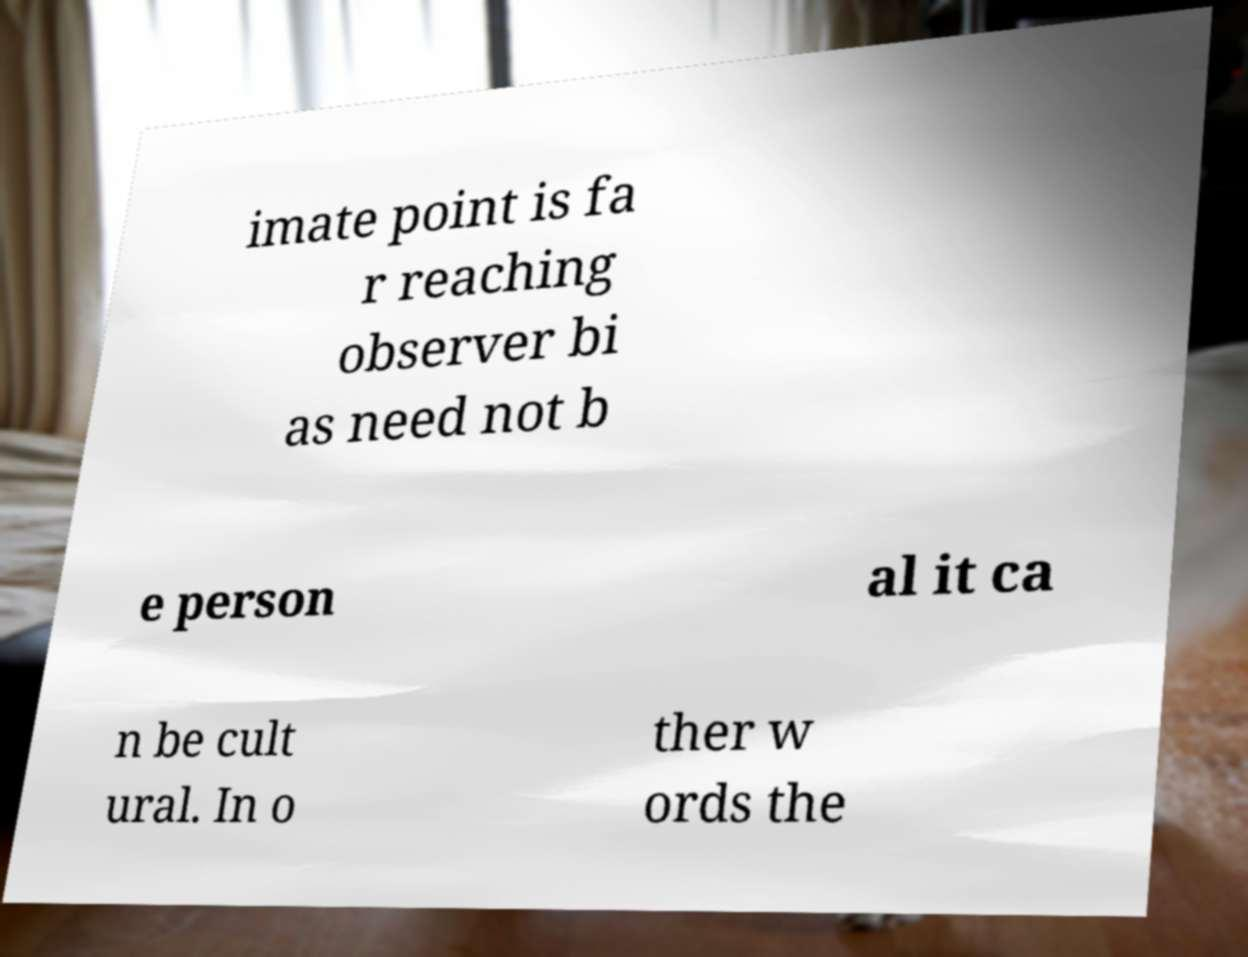I need the written content from this picture converted into text. Can you do that? imate point is fa r reaching observer bi as need not b e person al it ca n be cult ural. In o ther w ords the 